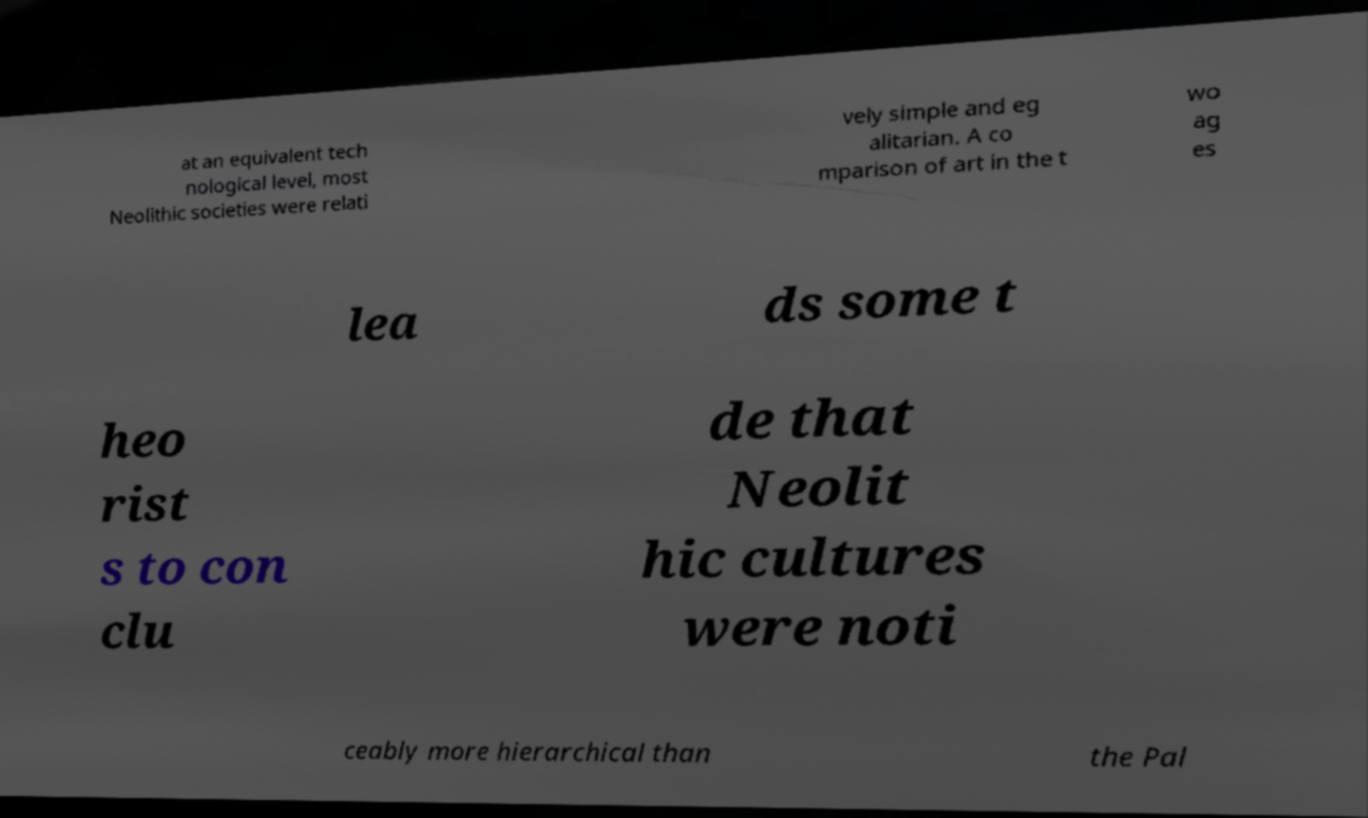Could you assist in decoding the text presented in this image and type it out clearly? at an equivalent tech nological level, most Neolithic societies were relati vely simple and eg alitarian. A co mparison of art in the t wo ag es lea ds some t heo rist s to con clu de that Neolit hic cultures were noti ceably more hierarchical than the Pal 